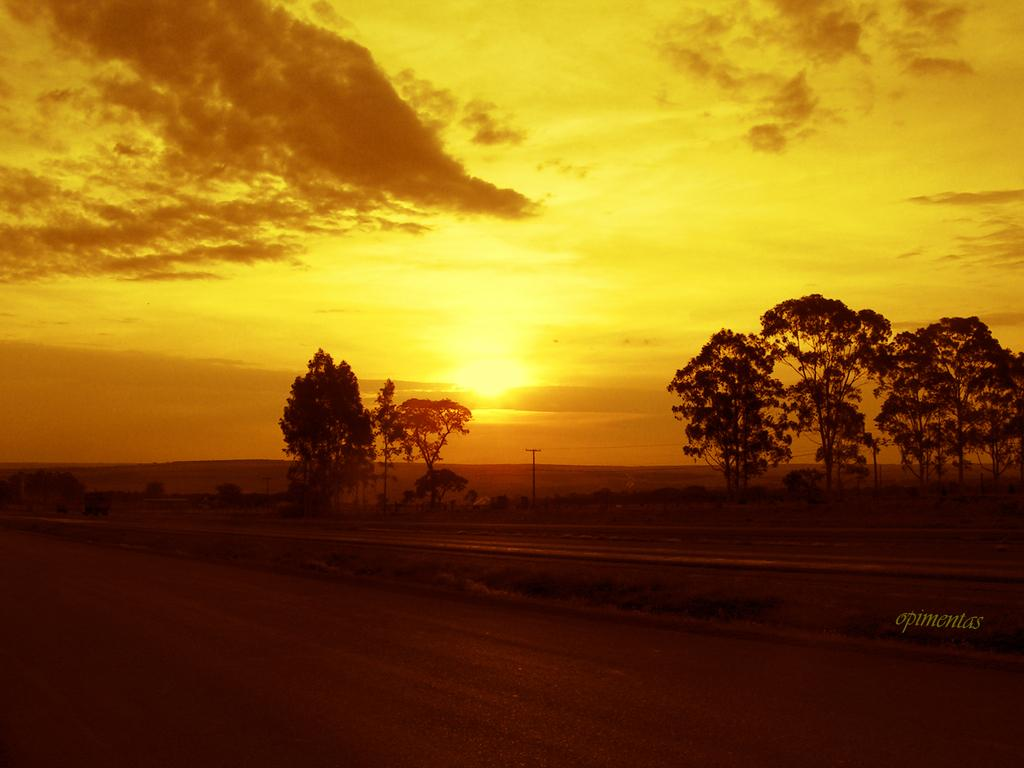What type of terrain is visible in the image? There is ground visible in the image. What type of vegetation can be seen in the image? There are trees in the image. What object is present in the image that is not a natural element? There is a pole in the image. What is visible in the background of the image? The sky is visible in the background of the image. Can the sun be seen in the image? Yes, the sun is observable in the sky. What is the tendency of the pencil in the image? There is no pencil present in the image. What type of class is being held in the image? There is no class or indication of a class being held in the image. 